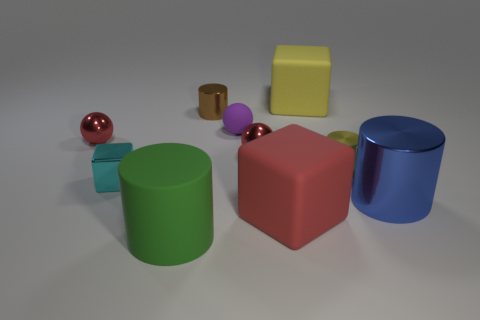Subtract 1 cylinders. How many cylinders are left? 3 Subtract all red cylinders. Subtract all gray cubes. How many cylinders are left? 4 Subtract all cubes. How many objects are left? 7 Subtract all green cylinders. Subtract all purple shiny spheres. How many objects are left? 9 Add 6 purple matte things. How many purple matte things are left? 7 Add 2 blue cylinders. How many blue cylinders exist? 3 Subtract 0 red cylinders. How many objects are left? 10 